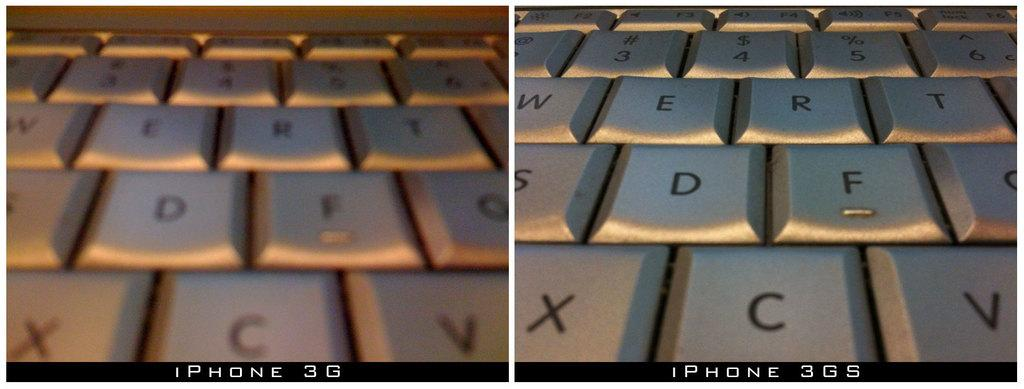<image>
Summarize the visual content of the image. two comparison pictures with one labeled iphone 3g and the second labeled 3gs 